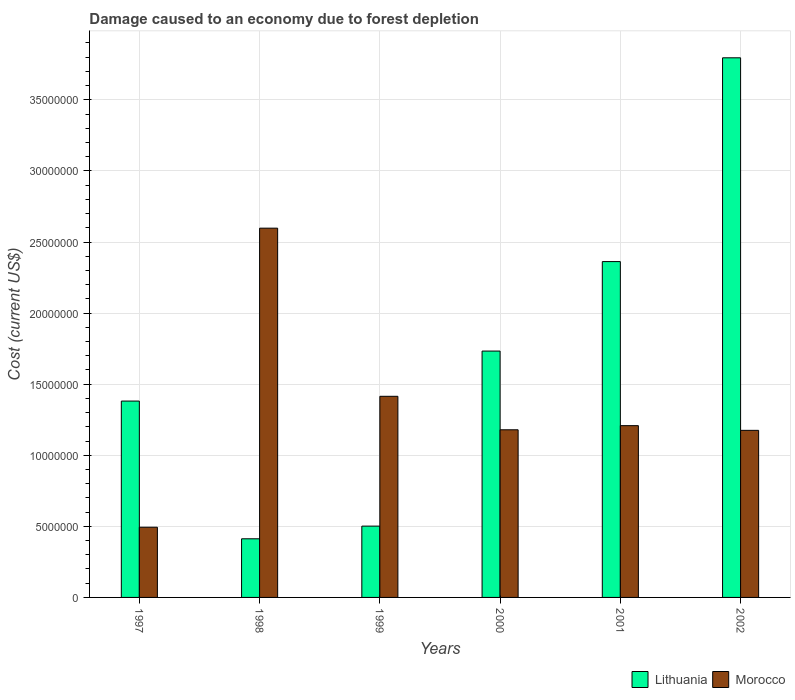How many different coloured bars are there?
Give a very brief answer. 2. How many groups of bars are there?
Ensure brevity in your answer.  6. Are the number of bars on each tick of the X-axis equal?
Offer a terse response. Yes. How many bars are there on the 2nd tick from the left?
Provide a succinct answer. 2. What is the label of the 2nd group of bars from the left?
Ensure brevity in your answer.  1998. What is the cost of damage caused due to forest depletion in Lithuania in 1999?
Ensure brevity in your answer.  5.02e+06. Across all years, what is the maximum cost of damage caused due to forest depletion in Morocco?
Offer a terse response. 2.60e+07. Across all years, what is the minimum cost of damage caused due to forest depletion in Lithuania?
Give a very brief answer. 4.12e+06. In which year was the cost of damage caused due to forest depletion in Lithuania minimum?
Make the answer very short. 1998. What is the total cost of damage caused due to forest depletion in Lithuania in the graph?
Give a very brief answer. 1.02e+08. What is the difference between the cost of damage caused due to forest depletion in Lithuania in 1998 and that in 2000?
Give a very brief answer. -1.32e+07. What is the difference between the cost of damage caused due to forest depletion in Lithuania in 1997 and the cost of damage caused due to forest depletion in Morocco in 2001?
Make the answer very short. 1.73e+06. What is the average cost of damage caused due to forest depletion in Lithuania per year?
Your answer should be very brief. 1.70e+07. In the year 1998, what is the difference between the cost of damage caused due to forest depletion in Lithuania and cost of damage caused due to forest depletion in Morocco?
Make the answer very short. -2.18e+07. What is the ratio of the cost of damage caused due to forest depletion in Morocco in 1999 to that in 2001?
Your response must be concise. 1.17. What is the difference between the highest and the second highest cost of damage caused due to forest depletion in Lithuania?
Provide a succinct answer. 1.43e+07. What is the difference between the highest and the lowest cost of damage caused due to forest depletion in Morocco?
Give a very brief answer. 2.10e+07. Is the sum of the cost of damage caused due to forest depletion in Lithuania in 1997 and 1999 greater than the maximum cost of damage caused due to forest depletion in Morocco across all years?
Give a very brief answer. No. What does the 2nd bar from the left in 2000 represents?
Your answer should be very brief. Morocco. What does the 1st bar from the right in 2001 represents?
Offer a terse response. Morocco. How many bars are there?
Ensure brevity in your answer.  12. How many years are there in the graph?
Provide a succinct answer. 6. How many legend labels are there?
Provide a succinct answer. 2. How are the legend labels stacked?
Your response must be concise. Horizontal. What is the title of the graph?
Your response must be concise. Damage caused to an economy due to forest depletion. Does "High income: OECD" appear as one of the legend labels in the graph?
Provide a short and direct response. No. What is the label or title of the Y-axis?
Offer a terse response. Cost (current US$). What is the Cost (current US$) in Lithuania in 1997?
Provide a succinct answer. 1.38e+07. What is the Cost (current US$) in Morocco in 1997?
Provide a succinct answer. 4.94e+06. What is the Cost (current US$) of Lithuania in 1998?
Your answer should be compact. 4.12e+06. What is the Cost (current US$) in Morocco in 1998?
Make the answer very short. 2.60e+07. What is the Cost (current US$) in Lithuania in 1999?
Offer a very short reply. 5.02e+06. What is the Cost (current US$) of Morocco in 1999?
Ensure brevity in your answer.  1.41e+07. What is the Cost (current US$) of Lithuania in 2000?
Provide a succinct answer. 1.73e+07. What is the Cost (current US$) in Morocco in 2000?
Keep it short and to the point. 1.18e+07. What is the Cost (current US$) of Lithuania in 2001?
Your answer should be compact. 2.36e+07. What is the Cost (current US$) of Morocco in 2001?
Your answer should be very brief. 1.21e+07. What is the Cost (current US$) in Lithuania in 2002?
Offer a very short reply. 3.80e+07. What is the Cost (current US$) in Morocco in 2002?
Ensure brevity in your answer.  1.18e+07. Across all years, what is the maximum Cost (current US$) in Lithuania?
Your answer should be compact. 3.80e+07. Across all years, what is the maximum Cost (current US$) of Morocco?
Your response must be concise. 2.60e+07. Across all years, what is the minimum Cost (current US$) in Lithuania?
Ensure brevity in your answer.  4.12e+06. Across all years, what is the minimum Cost (current US$) in Morocco?
Keep it short and to the point. 4.94e+06. What is the total Cost (current US$) in Lithuania in the graph?
Ensure brevity in your answer.  1.02e+08. What is the total Cost (current US$) of Morocco in the graph?
Keep it short and to the point. 8.07e+07. What is the difference between the Cost (current US$) of Lithuania in 1997 and that in 1998?
Provide a succinct answer. 9.69e+06. What is the difference between the Cost (current US$) in Morocco in 1997 and that in 1998?
Offer a very short reply. -2.10e+07. What is the difference between the Cost (current US$) of Lithuania in 1997 and that in 1999?
Offer a very short reply. 8.80e+06. What is the difference between the Cost (current US$) of Morocco in 1997 and that in 1999?
Your response must be concise. -9.21e+06. What is the difference between the Cost (current US$) in Lithuania in 1997 and that in 2000?
Provide a succinct answer. -3.52e+06. What is the difference between the Cost (current US$) in Morocco in 1997 and that in 2000?
Keep it short and to the point. -6.85e+06. What is the difference between the Cost (current US$) in Lithuania in 1997 and that in 2001?
Provide a short and direct response. -9.81e+06. What is the difference between the Cost (current US$) of Morocco in 1997 and that in 2001?
Give a very brief answer. -7.15e+06. What is the difference between the Cost (current US$) of Lithuania in 1997 and that in 2002?
Keep it short and to the point. -2.41e+07. What is the difference between the Cost (current US$) in Morocco in 1997 and that in 2002?
Ensure brevity in your answer.  -6.81e+06. What is the difference between the Cost (current US$) of Lithuania in 1998 and that in 1999?
Make the answer very short. -8.92e+05. What is the difference between the Cost (current US$) of Morocco in 1998 and that in 1999?
Keep it short and to the point. 1.18e+07. What is the difference between the Cost (current US$) of Lithuania in 1998 and that in 2000?
Your answer should be very brief. -1.32e+07. What is the difference between the Cost (current US$) in Morocco in 1998 and that in 2000?
Provide a short and direct response. 1.42e+07. What is the difference between the Cost (current US$) in Lithuania in 1998 and that in 2001?
Your answer should be compact. -1.95e+07. What is the difference between the Cost (current US$) in Morocco in 1998 and that in 2001?
Give a very brief answer. 1.39e+07. What is the difference between the Cost (current US$) of Lithuania in 1998 and that in 2002?
Offer a very short reply. -3.38e+07. What is the difference between the Cost (current US$) of Morocco in 1998 and that in 2002?
Give a very brief answer. 1.42e+07. What is the difference between the Cost (current US$) in Lithuania in 1999 and that in 2000?
Your response must be concise. -1.23e+07. What is the difference between the Cost (current US$) of Morocco in 1999 and that in 2000?
Your response must be concise. 2.36e+06. What is the difference between the Cost (current US$) in Lithuania in 1999 and that in 2001?
Your answer should be very brief. -1.86e+07. What is the difference between the Cost (current US$) of Morocco in 1999 and that in 2001?
Make the answer very short. 2.06e+06. What is the difference between the Cost (current US$) of Lithuania in 1999 and that in 2002?
Give a very brief answer. -3.29e+07. What is the difference between the Cost (current US$) in Morocco in 1999 and that in 2002?
Make the answer very short. 2.40e+06. What is the difference between the Cost (current US$) in Lithuania in 2000 and that in 2001?
Keep it short and to the point. -6.29e+06. What is the difference between the Cost (current US$) in Morocco in 2000 and that in 2001?
Your response must be concise. -2.92e+05. What is the difference between the Cost (current US$) in Lithuania in 2000 and that in 2002?
Provide a short and direct response. -2.06e+07. What is the difference between the Cost (current US$) in Morocco in 2000 and that in 2002?
Your response must be concise. 3.97e+04. What is the difference between the Cost (current US$) in Lithuania in 2001 and that in 2002?
Make the answer very short. -1.43e+07. What is the difference between the Cost (current US$) of Morocco in 2001 and that in 2002?
Your answer should be compact. 3.32e+05. What is the difference between the Cost (current US$) of Lithuania in 1997 and the Cost (current US$) of Morocco in 1998?
Make the answer very short. -1.22e+07. What is the difference between the Cost (current US$) in Lithuania in 1997 and the Cost (current US$) in Morocco in 1999?
Offer a terse response. -3.35e+05. What is the difference between the Cost (current US$) of Lithuania in 1997 and the Cost (current US$) of Morocco in 2000?
Give a very brief answer. 2.02e+06. What is the difference between the Cost (current US$) of Lithuania in 1997 and the Cost (current US$) of Morocco in 2001?
Make the answer very short. 1.73e+06. What is the difference between the Cost (current US$) of Lithuania in 1997 and the Cost (current US$) of Morocco in 2002?
Provide a succinct answer. 2.06e+06. What is the difference between the Cost (current US$) in Lithuania in 1998 and the Cost (current US$) in Morocco in 1999?
Give a very brief answer. -1.00e+07. What is the difference between the Cost (current US$) of Lithuania in 1998 and the Cost (current US$) of Morocco in 2000?
Your answer should be compact. -7.67e+06. What is the difference between the Cost (current US$) in Lithuania in 1998 and the Cost (current US$) in Morocco in 2001?
Give a very brief answer. -7.96e+06. What is the difference between the Cost (current US$) in Lithuania in 1998 and the Cost (current US$) in Morocco in 2002?
Ensure brevity in your answer.  -7.63e+06. What is the difference between the Cost (current US$) of Lithuania in 1999 and the Cost (current US$) of Morocco in 2000?
Make the answer very short. -6.77e+06. What is the difference between the Cost (current US$) of Lithuania in 1999 and the Cost (current US$) of Morocco in 2001?
Offer a very short reply. -7.07e+06. What is the difference between the Cost (current US$) of Lithuania in 1999 and the Cost (current US$) of Morocco in 2002?
Keep it short and to the point. -6.74e+06. What is the difference between the Cost (current US$) in Lithuania in 2000 and the Cost (current US$) in Morocco in 2001?
Offer a very short reply. 5.25e+06. What is the difference between the Cost (current US$) in Lithuania in 2000 and the Cost (current US$) in Morocco in 2002?
Your answer should be very brief. 5.58e+06. What is the difference between the Cost (current US$) in Lithuania in 2001 and the Cost (current US$) in Morocco in 2002?
Make the answer very short. 1.19e+07. What is the average Cost (current US$) in Lithuania per year?
Make the answer very short. 1.70e+07. What is the average Cost (current US$) of Morocco per year?
Provide a short and direct response. 1.34e+07. In the year 1997, what is the difference between the Cost (current US$) in Lithuania and Cost (current US$) in Morocco?
Your answer should be compact. 8.87e+06. In the year 1998, what is the difference between the Cost (current US$) of Lithuania and Cost (current US$) of Morocco?
Keep it short and to the point. -2.18e+07. In the year 1999, what is the difference between the Cost (current US$) of Lithuania and Cost (current US$) of Morocco?
Provide a short and direct response. -9.13e+06. In the year 2000, what is the difference between the Cost (current US$) of Lithuania and Cost (current US$) of Morocco?
Your answer should be very brief. 5.54e+06. In the year 2001, what is the difference between the Cost (current US$) in Lithuania and Cost (current US$) in Morocco?
Offer a terse response. 1.15e+07. In the year 2002, what is the difference between the Cost (current US$) of Lithuania and Cost (current US$) of Morocco?
Give a very brief answer. 2.62e+07. What is the ratio of the Cost (current US$) of Lithuania in 1997 to that in 1998?
Provide a short and direct response. 3.35. What is the ratio of the Cost (current US$) in Morocco in 1997 to that in 1998?
Provide a short and direct response. 0.19. What is the ratio of the Cost (current US$) of Lithuania in 1997 to that in 1999?
Your answer should be compact. 2.75. What is the ratio of the Cost (current US$) of Morocco in 1997 to that in 1999?
Make the answer very short. 0.35. What is the ratio of the Cost (current US$) in Lithuania in 1997 to that in 2000?
Ensure brevity in your answer.  0.8. What is the ratio of the Cost (current US$) of Morocco in 1997 to that in 2000?
Your answer should be compact. 0.42. What is the ratio of the Cost (current US$) of Lithuania in 1997 to that in 2001?
Offer a very short reply. 0.58. What is the ratio of the Cost (current US$) in Morocco in 1997 to that in 2001?
Provide a succinct answer. 0.41. What is the ratio of the Cost (current US$) in Lithuania in 1997 to that in 2002?
Your response must be concise. 0.36. What is the ratio of the Cost (current US$) of Morocco in 1997 to that in 2002?
Make the answer very short. 0.42. What is the ratio of the Cost (current US$) in Lithuania in 1998 to that in 1999?
Give a very brief answer. 0.82. What is the ratio of the Cost (current US$) of Morocco in 1998 to that in 1999?
Your answer should be compact. 1.84. What is the ratio of the Cost (current US$) of Lithuania in 1998 to that in 2000?
Your answer should be compact. 0.24. What is the ratio of the Cost (current US$) of Morocco in 1998 to that in 2000?
Provide a short and direct response. 2.2. What is the ratio of the Cost (current US$) of Lithuania in 1998 to that in 2001?
Keep it short and to the point. 0.17. What is the ratio of the Cost (current US$) of Morocco in 1998 to that in 2001?
Your answer should be very brief. 2.15. What is the ratio of the Cost (current US$) of Lithuania in 1998 to that in 2002?
Offer a terse response. 0.11. What is the ratio of the Cost (current US$) of Morocco in 1998 to that in 2002?
Give a very brief answer. 2.21. What is the ratio of the Cost (current US$) of Lithuania in 1999 to that in 2000?
Provide a succinct answer. 0.29. What is the ratio of the Cost (current US$) in Morocco in 1999 to that in 2000?
Offer a very short reply. 1.2. What is the ratio of the Cost (current US$) in Lithuania in 1999 to that in 2001?
Offer a very short reply. 0.21. What is the ratio of the Cost (current US$) in Morocco in 1999 to that in 2001?
Your answer should be very brief. 1.17. What is the ratio of the Cost (current US$) in Lithuania in 1999 to that in 2002?
Give a very brief answer. 0.13. What is the ratio of the Cost (current US$) of Morocco in 1999 to that in 2002?
Provide a succinct answer. 1.2. What is the ratio of the Cost (current US$) of Lithuania in 2000 to that in 2001?
Provide a short and direct response. 0.73. What is the ratio of the Cost (current US$) in Morocco in 2000 to that in 2001?
Keep it short and to the point. 0.98. What is the ratio of the Cost (current US$) in Lithuania in 2000 to that in 2002?
Offer a terse response. 0.46. What is the ratio of the Cost (current US$) of Lithuania in 2001 to that in 2002?
Give a very brief answer. 0.62. What is the ratio of the Cost (current US$) of Morocco in 2001 to that in 2002?
Make the answer very short. 1.03. What is the difference between the highest and the second highest Cost (current US$) in Lithuania?
Offer a terse response. 1.43e+07. What is the difference between the highest and the second highest Cost (current US$) of Morocco?
Offer a terse response. 1.18e+07. What is the difference between the highest and the lowest Cost (current US$) in Lithuania?
Provide a succinct answer. 3.38e+07. What is the difference between the highest and the lowest Cost (current US$) in Morocco?
Offer a very short reply. 2.10e+07. 